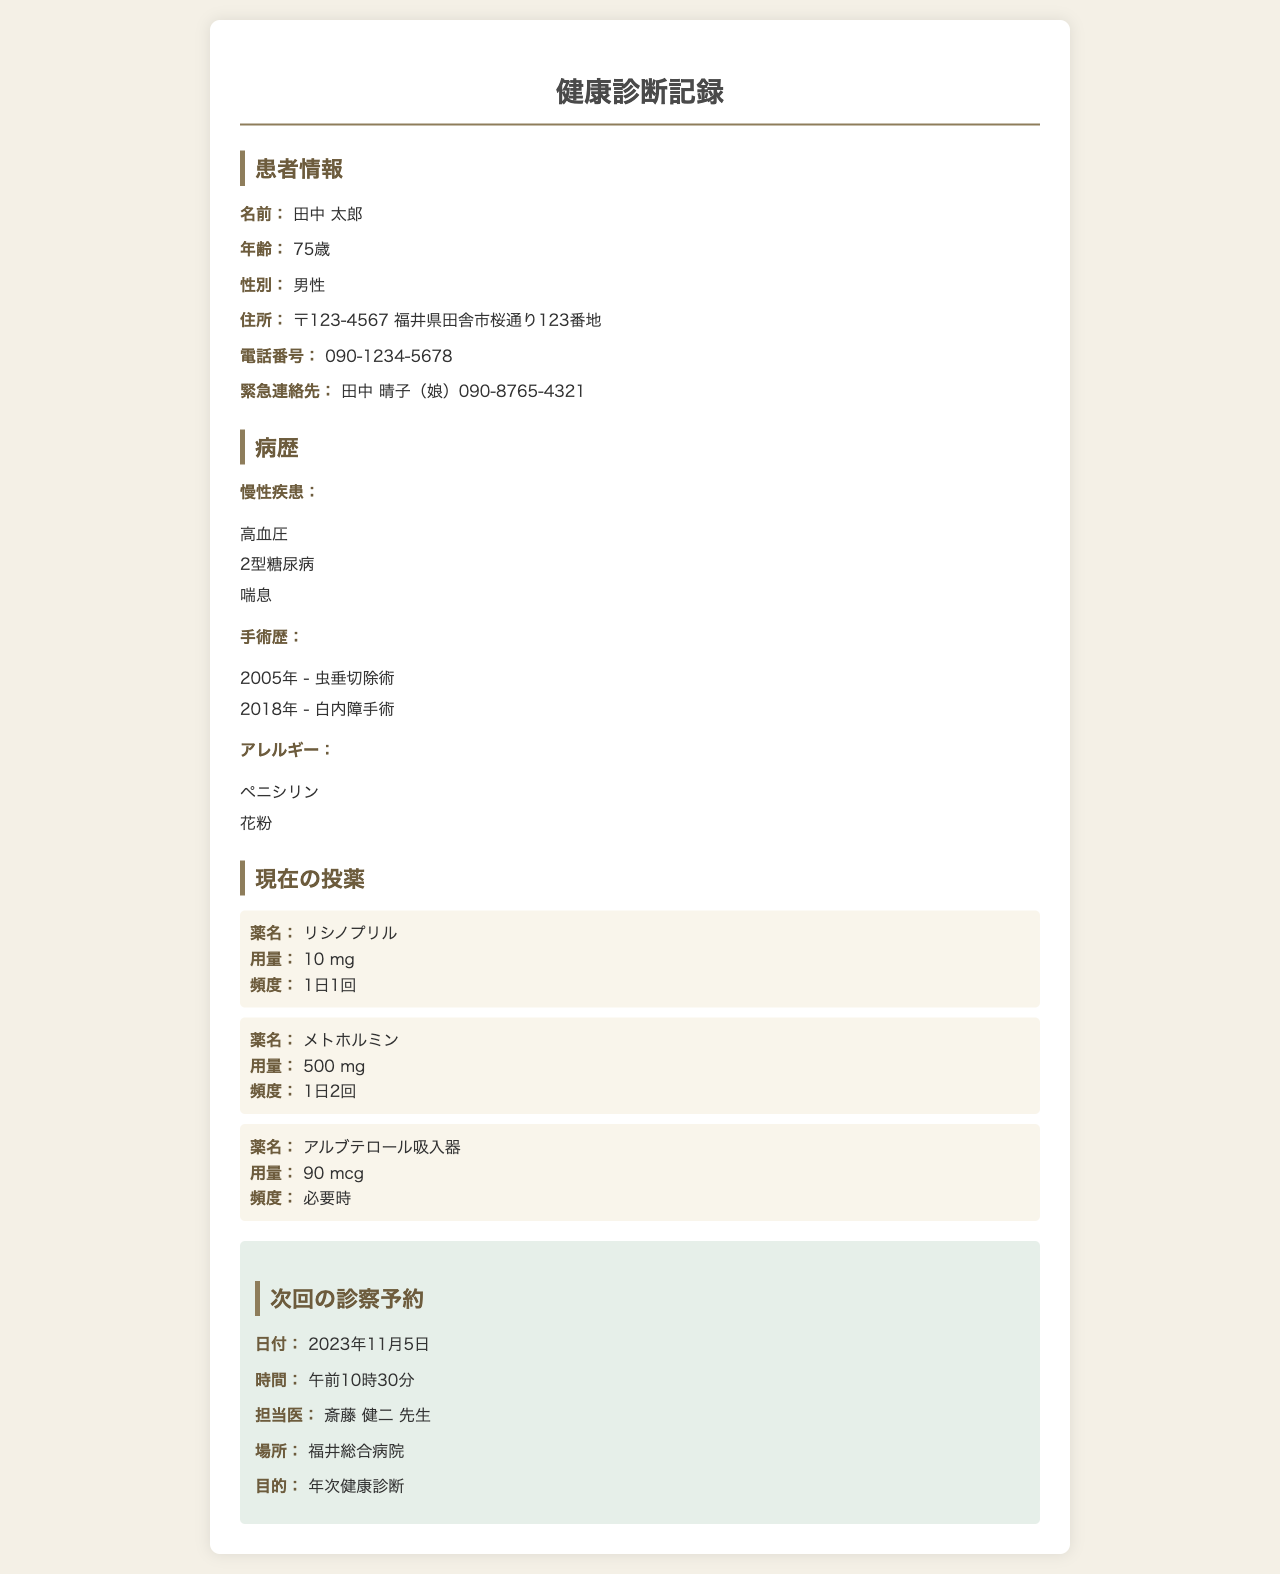患者の名前は何ですか？ 患者情報のセクションに記載されています。
Answer: 田中 太郎 田中さんの年齢はいくつですか？ 患者情報のセクションに年齢が示されています。
Answer: 75歳 慢性疾患には何がありますか？ 病歴のセクションに高血圧、2型糖尿病、喘息が記載されています。
Answer: 高血圧、2型糖尿病、喘息 次回の診察予約日はいつですか？ 次回の診察予約に関する情報が提供されています。
Answer: 2023年11月5日 担当医は誰ですか？ 次回の診察予約セクションに担当医の名前が記載されています。
Answer: 斎藤 健二 先生 田中さんのアレルギーは何ですか？ 病歴のセクションにアレルギーに関する情報があります。
Answer: ペニシリン、花粉 次回の診察の目的は何ですか？ 次回の診察予約セクションに目的が述べられています。
Answer: 年次健康診断 田中さんの電話番号は何ですか？ 患者情報セクションに電話番号が示されています。
Answer: 090-1234-5678 田中さんが服用している薬の頻度はどのようになっていますか？ 現在の投薬セクションに投薬の頻度が詳細に説明されています。
Answer: 1日1回、1日2回、必要時 